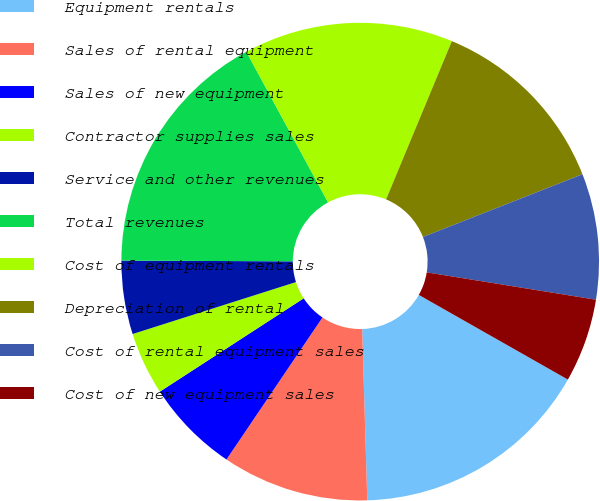Convert chart to OTSL. <chart><loc_0><loc_0><loc_500><loc_500><pie_chart><fcel>Equipment rentals<fcel>Sales of rental equipment<fcel>Sales of new equipment<fcel>Contractor supplies sales<fcel>Service and other revenues<fcel>Total revenues<fcel>Cost of equipment rentals<fcel>Depreciation of rental<fcel>Cost of rental equipment sales<fcel>Cost of new equipment sales<nl><fcel>16.31%<fcel>9.93%<fcel>6.38%<fcel>4.26%<fcel>4.97%<fcel>17.02%<fcel>14.18%<fcel>12.77%<fcel>8.51%<fcel>5.67%<nl></chart> 